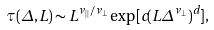<formula> <loc_0><loc_0><loc_500><loc_500>\tau ( \Delta , L ) \sim L ^ { \nu _ { | | } / \nu _ { \perp } } \exp [ c ( L \Delta ^ { \nu _ { \perp } } ) ^ { d } ] ,</formula> 